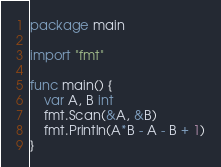<code> <loc_0><loc_0><loc_500><loc_500><_Go_>package main

import "fmt"

func main() {
	var A, B int
	fmt.Scan(&A, &B)
	fmt.Println(A*B - A - B + 1)
}
</code> 